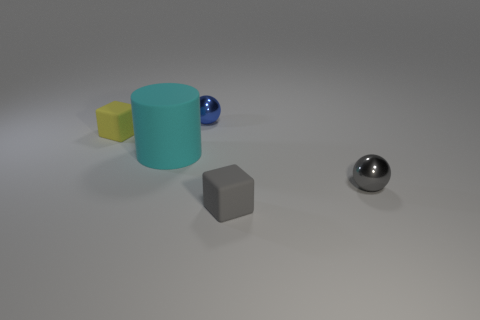What material is the other object that is the same shape as the blue metal object?
Offer a terse response. Metal. How many big matte things are the same shape as the small gray rubber object?
Keep it short and to the point. 0. There is a small block that is to the left of the metallic object behind the metallic ball in front of the big cylinder; what is it made of?
Offer a terse response. Rubber. What is the shape of the yellow matte object that is the same size as the gray matte object?
Provide a short and direct response. Cube. Is there a tiny rubber object that has the same color as the large rubber cylinder?
Ensure brevity in your answer.  No. What is the size of the gray matte cube?
Your answer should be compact. Small. Are the big cyan cylinder and the tiny gray ball made of the same material?
Your answer should be very brief. No. There is a metal ball left of the small rubber thing that is on the right side of the small blue metal ball; how many tiny blocks are on the left side of it?
Provide a succinct answer. 1. The tiny rubber thing to the right of the big cylinder has what shape?
Make the answer very short. Cube. What number of other things are there of the same material as the gray sphere
Your answer should be very brief. 1. 